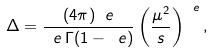Convert formula to latex. <formula><loc_0><loc_0><loc_500><loc_500>\Delta = \frac { ( 4 \pi ) ^ { \ } e } { \ e \, \Gamma ( 1 - \ e ) } \left ( \frac { \mu ^ { 2 } } { s } \right ) ^ { \ e } ,</formula> 